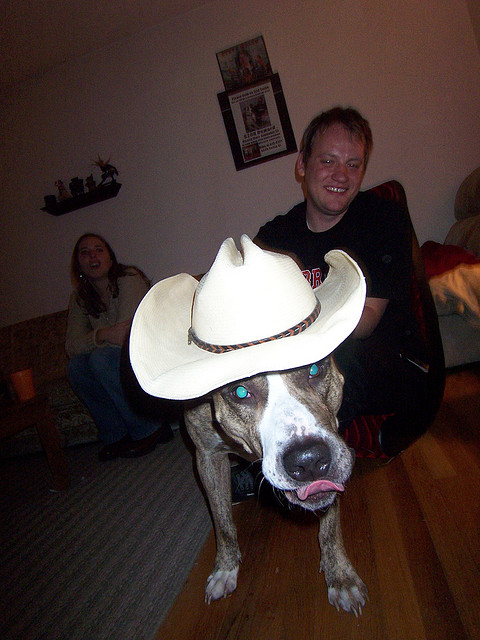Please extract the text content from this image. R 